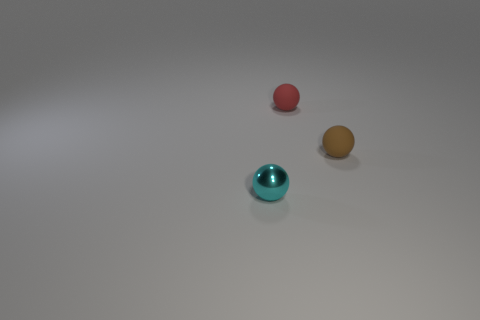Add 2 large cyan blocks. How many objects exist? 5 Subtract all brown matte things. Subtract all brown things. How many objects are left? 1 Add 2 red spheres. How many red spheres are left? 3 Add 1 small green shiny blocks. How many small green shiny blocks exist? 1 Subtract 0 yellow cylinders. How many objects are left? 3 